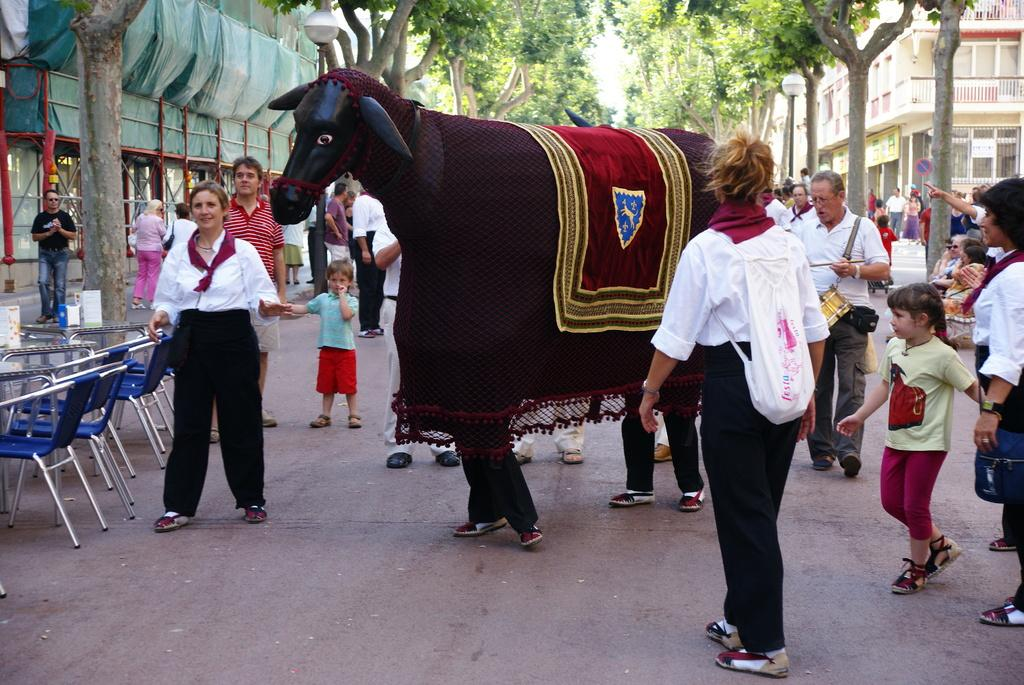What are the men in the image doing? The men in the image are standing on the road. What other objects or figures can be seen in the image? There is a doll, trees, a building, a light pole on the left side, chairs, and a table in the image. What type of arithmetic problem can be solved using the chairs and table in the image? There is no arithmetic problem present in the image, as it features men standing on the road, a doll, trees, a building, a light pole, chairs, and a table. 